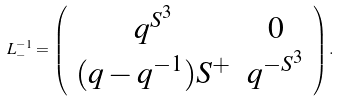Convert formula to latex. <formula><loc_0><loc_0><loc_500><loc_500>L ^ { - 1 } _ { - } = \left ( \begin{array} { c c } q ^ { S ^ { 3 } } & 0 \\ ( q - q ^ { - 1 } ) S ^ { + } & q ^ { - S ^ { 3 } } \end{array} \right ) .</formula> 